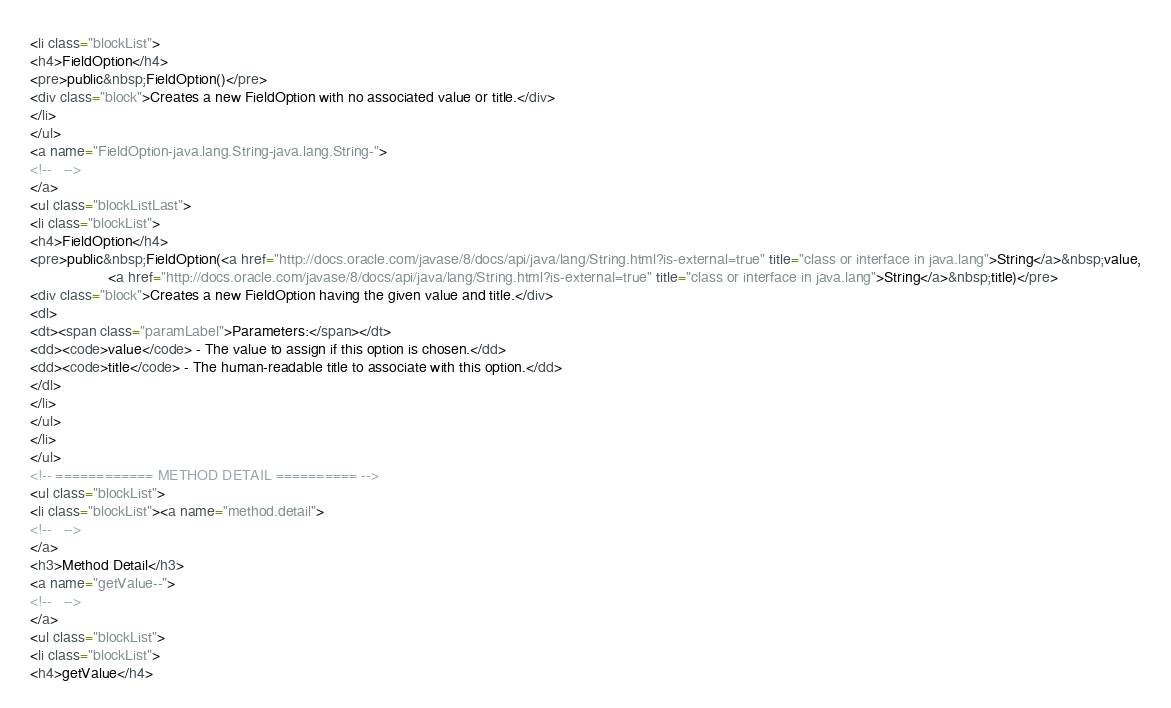<code> <loc_0><loc_0><loc_500><loc_500><_HTML_><li class="blockList">
<h4>FieldOption</h4>
<pre>public&nbsp;FieldOption()</pre>
<div class="block">Creates a new FieldOption with no associated value or title.</div>
</li>
</ul>
<a name="FieldOption-java.lang.String-java.lang.String-">
<!--   -->
</a>
<ul class="blockListLast">
<li class="blockList">
<h4>FieldOption</h4>
<pre>public&nbsp;FieldOption(<a href="http://docs.oracle.com/javase/8/docs/api/java/lang/String.html?is-external=true" title="class or interface in java.lang">String</a>&nbsp;value,
                   <a href="http://docs.oracle.com/javase/8/docs/api/java/lang/String.html?is-external=true" title="class or interface in java.lang">String</a>&nbsp;title)</pre>
<div class="block">Creates a new FieldOption having the given value and title.</div>
<dl>
<dt><span class="paramLabel">Parameters:</span></dt>
<dd><code>value</code> - The value to assign if this option is chosen.</dd>
<dd><code>title</code> - The human-readable title to associate with this option.</dd>
</dl>
</li>
</ul>
</li>
</ul>
<!-- ============ METHOD DETAIL ========== -->
<ul class="blockList">
<li class="blockList"><a name="method.detail">
<!--   -->
</a>
<h3>Method Detail</h3>
<a name="getValue--">
<!--   -->
</a>
<ul class="blockList">
<li class="blockList">
<h4>getValue</h4></code> 